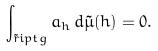Convert formula to latex. <formula><loc_0><loc_0><loc_500><loc_500>\int _ { \tilde { r } i p t g } a _ { h } \, d \tilde { \mu } ( h ) = 0 .</formula> 